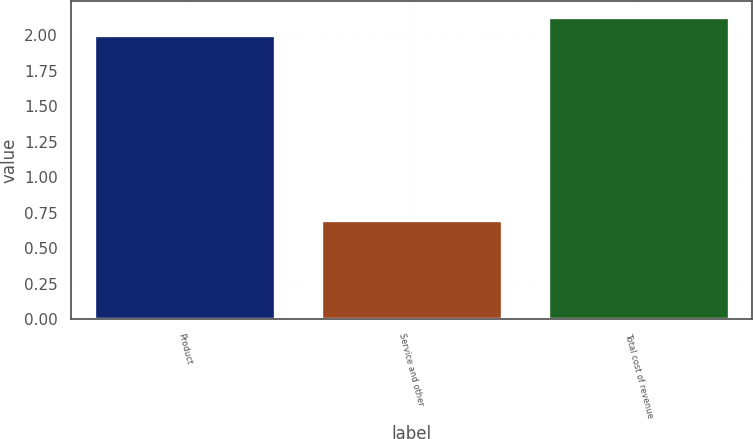<chart> <loc_0><loc_0><loc_500><loc_500><bar_chart><fcel>Product<fcel>Service and other<fcel>Total cost of revenue<nl><fcel>2<fcel>0.7<fcel>2.13<nl></chart> 